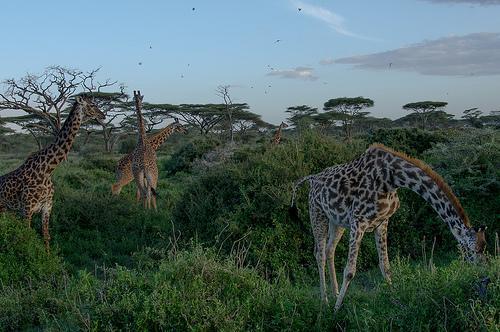How many giraffes are shown?
Give a very brief answer. 5. 